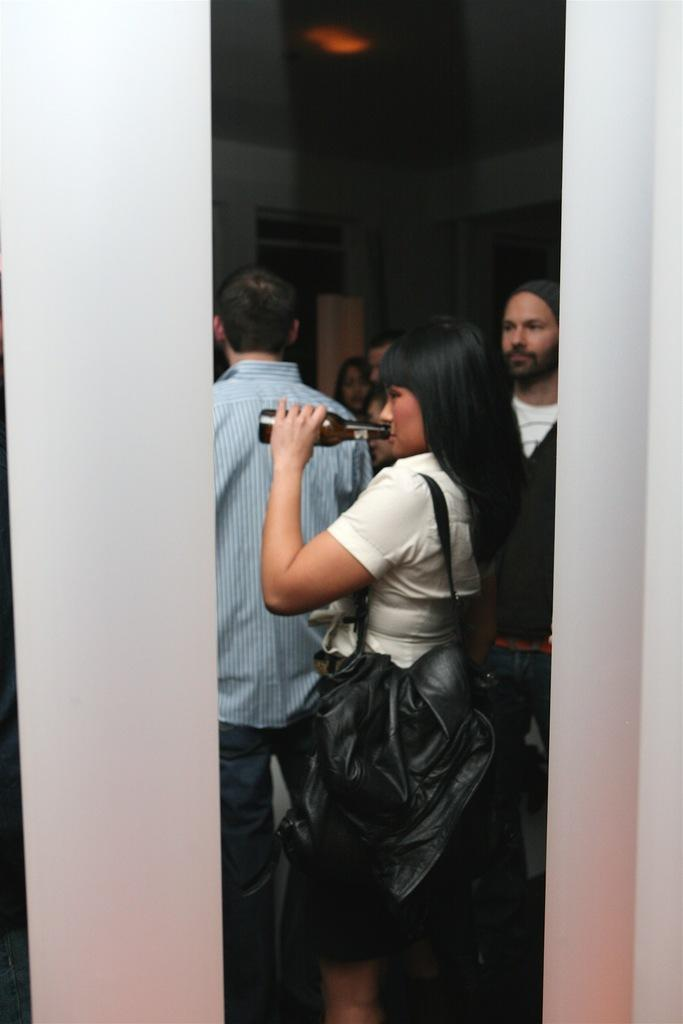Who is the main subject in the image? There is a lady in the image. What is the lady holding in the image? The lady is holding a bottle. Can you describe the background of the image? There are people visible behind the lady. What is the source of illumination in the image? There is light in the image. How many trees are visible behind the lady in the image? There are no trees visible behind the lady in the image. What grade is the lady in the image? The image does not provide any information about the lady's grade or educational level. 